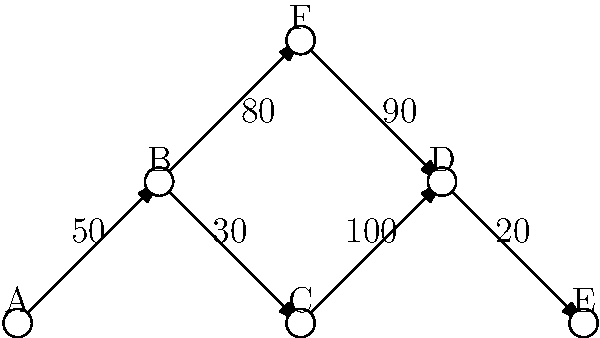Given the network graph visualization above representing data flow between servers (nodes) in a company's infrastructure, with edge labels indicating the number of connections per minute, which node is most likely to be the source of a potential data breach? To identify the potential source of a data breach, we need to analyze the network traffic patterns:

1. Examine the number of connections for each node:
   - Node A: 50 outgoing
   - Node B: 50 incoming, 30 + 80 = 110 outgoing
   - Node C: 30 incoming, 100 outgoing
   - Node D: 100 + 90 = 190 incoming, 20 outgoing
   - Node E: 20 incoming
   - Node F: 80 incoming, 90 outgoing

2. Look for anomalies in the traffic patterns:
   - Unusually high outgoing traffic compared to incoming traffic
   - Unexpected connections between nodes

3. Analyze each node:
   - Node A: Normal outgoing traffic
   - Node B: Slightly higher outgoing (110) than incoming (50)
   - Node C: Significantly higher outgoing (100) than incoming (30)
   - Node D: Much higher incoming (190) than outgoing (20)
   - Node E: Only incoming traffic, not suspicious
   - Node F: Slightly higher outgoing (90) than incoming (80)

4. Identify the most suspicious node:
   Node C shows the most significant disparity between incoming and outgoing traffic, with much higher outgoing connections (100) compared to incoming (30).

5. Conclusion:
   Node C is the most likely source of a potential data breach due to its unusually high outgoing traffic relative to incoming traffic, which could indicate unauthorized data exfiltration.
Answer: Node C 